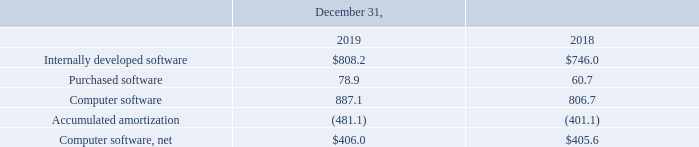(8) Computer Software
Computer software, net consists of the following (in millions):
In the fourth quarter of 2019, we entered into agreements to acquire software in exchange for a combination of cash consideration and certain of our products and services. The software was acquired for $32.0 million, of which software valued at $6.5 million was received as of December 31, 2019 and resulted in non-cash investing activity of $4.8 million.
What did the company do in the fourth quarter of 2019? Entered into agreements to acquire software in exchange for a combination of cash consideration and certain of our products and services. How much did the company acquire software for?
Answer scale should be: million. 32.0. What was the amount of internally developed software in 2019?
Answer scale should be: million. 808.2. What was the change in purchased software between 2018 and 2019?
Answer scale should be: million. 78.9-60.7
Answer: 18.2. How many years did internally developed software exceed $800 million? 2019
Answer: 1. What was the percentage change in net computer software between 2018 and 2019?
Answer scale should be: percent. (406.0-405.6)/405.6
Answer: 0.1. 